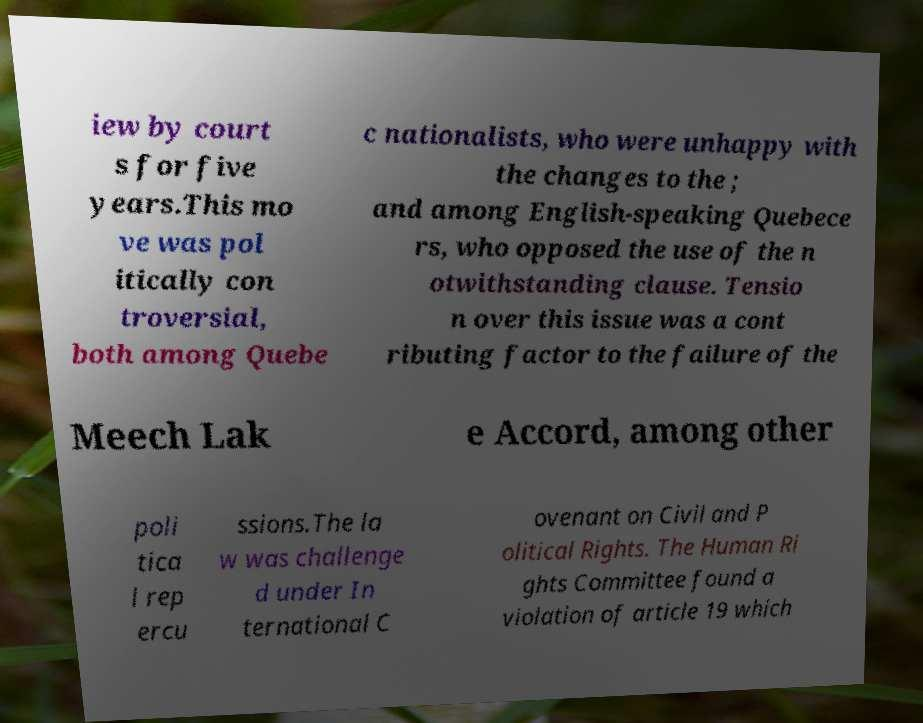Can you accurately transcribe the text from the provided image for me? iew by court s for five years.This mo ve was pol itically con troversial, both among Quebe c nationalists, who were unhappy with the changes to the ; and among English-speaking Quebece rs, who opposed the use of the n otwithstanding clause. Tensio n over this issue was a cont ributing factor to the failure of the Meech Lak e Accord, among other poli tica l rep ercu ssions.The la w was challenge d under In ternational C ovenant on Civil and P olitical Rights. The Human Ri ghts Committee found a violation of article 19 which 